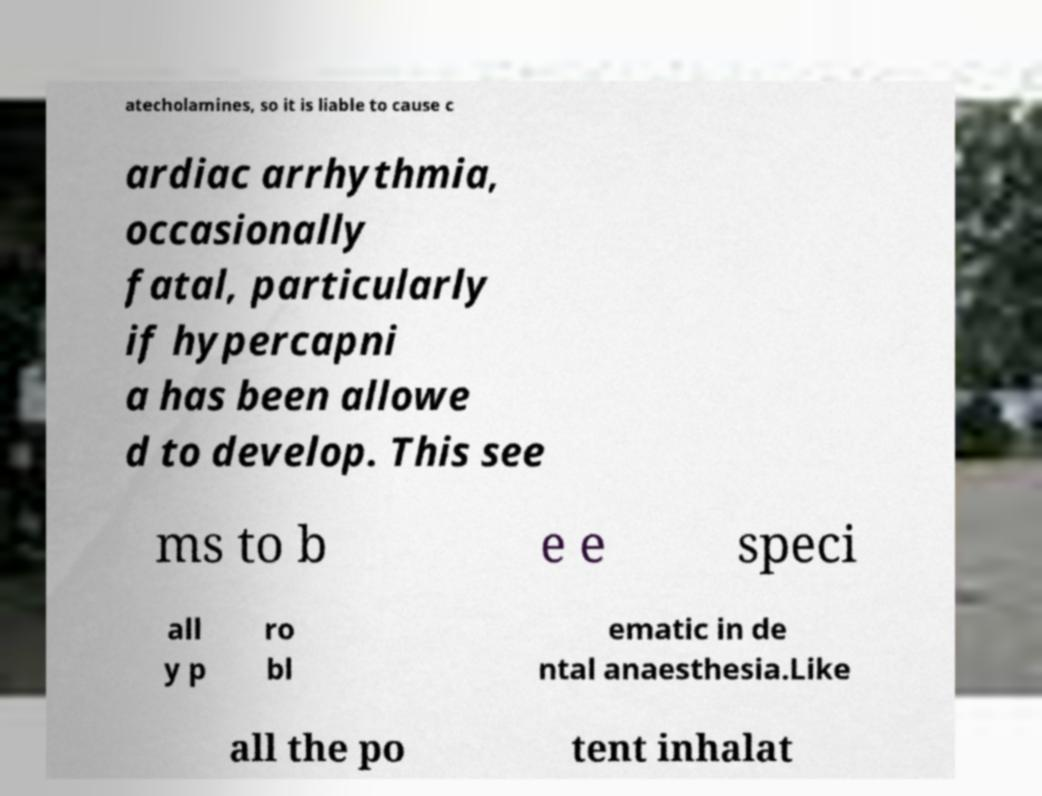Can you accurately transcribe the text from the provided image for me? atecholamines, so it is liable to cause c ardiac arrhythmia, occasionally fatal, particularly if hypercapni a has been allowe d to develop. This see ms to b e e speci all y p ro bl ematic in de ntal anaesthesia.Like all the po tent inhalat 